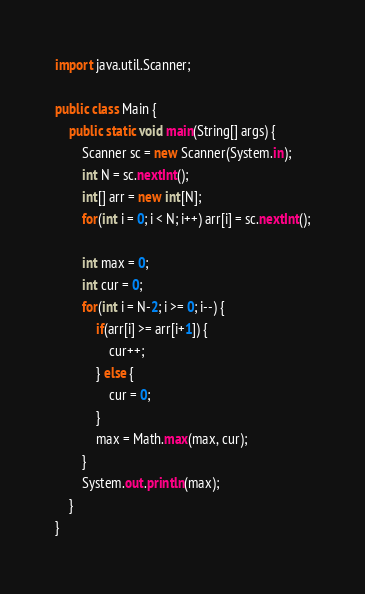Convert code to text. <code><loc_0><loc_0><loc_500><loc_500><_Java_>import java.util.Scanner;

public class Main {
    public static void main(String[] args) {
        Scanner sc = new Scanner(System.in);
        int N = sc.nextInt();
        int[] arr = new int[N];
        for(int i = 0; i < N; i++) arr[i] = sc.nextInt();

        int max = 0;
        int cur = 0;
        for(int i = N-2; i >= 0; i--) {
            if(arr[i] >= arr[i+1]) {
                cur++;
            } else {
                cur = 0;
            }
            max = Math.max(max, cur);
        }
        System.out.println(max);
    }
}
</code> 